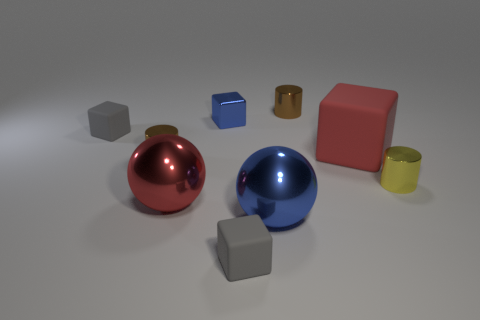What material is the big thing that is the same color as the metallic cube?
Offer a terse response. Metal. What number of things are either tiny metal things behind the tiny blue thing or large rubber cubes?
Ensure brevity in your answer.  2. What is the shape of the small gray thing that is behind the yellow cylinder?
Make the answer very short. Cube. Is the number of tiny yellow cylinders on the right side of the big red block the same as the number of spheres that are in front of the red metal thing?
Ensure brevity in your answer.  Yes. There is a shiny object that is both on the right side of the red shiny object and in front of the yellow thing; what color is it?
Keep it short and to the point. Blue. What is the material of the red thing that is behind the small yellow cylinder right of the large red matte thing?
Your answer should be very brief. Rubber. Does the blue block have the same size as the red sphere?
Keep it short and to the point. No. What number of small objects are brown objects or gray matte objects?
Offer a very short reply. 4. There is a yellow cylinder; what number of rubber cubes are in front of it?
Provide a succinct answer. 1. Is the number of large red shiny things that are right of the large red metallic object greater than the number of tiny red cubes?
Your response must be concise. No. 